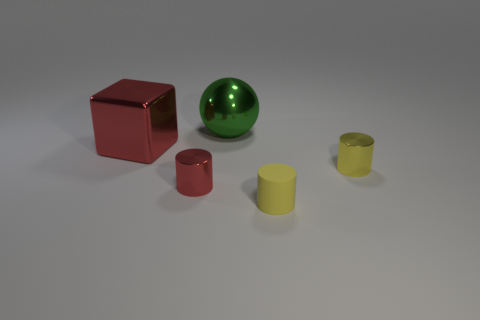Subtract all green cubes. How many yellow cylinders are left? 2 Subtract all small yellow matte cylinders. How many cylinders are left? 2 Subtract 1 cylinders. How many cylinders are left? 2 Add 1 large metal objects. How many objects exist? 6 Subtract all balls. How many objects are left? 4 Subtract all cyan cylinders. Subtract all cyan spheres. How many cylinders are left? 3 Subtract all small objects. Subtract all yellow cylinders. How many objects are left? 0 Add 1 small red cylinders. How many small red cylinders are left? 2 Add 2 big yellow rubber blocks. How many big yellow rubber blocks exist? 2 Subtract 0 blue spheres. How many objects are left? 5 